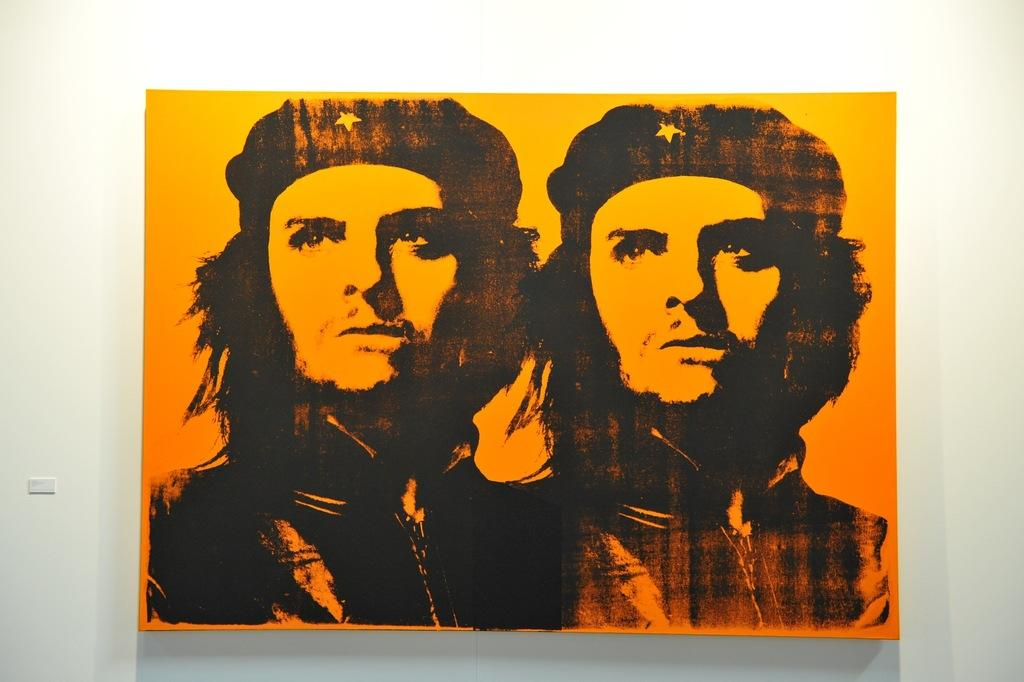What is the main object in the image? There is a frame in the image. What can be seen inside the frame? The frame contains two images of the same person. Where is the frame located in the image? The frame is attached to a wall. How many cobwebs can be seen on the top of the frame in the image? There are no cobwebs visible in the image, as the focus is on the frame and its contents. 